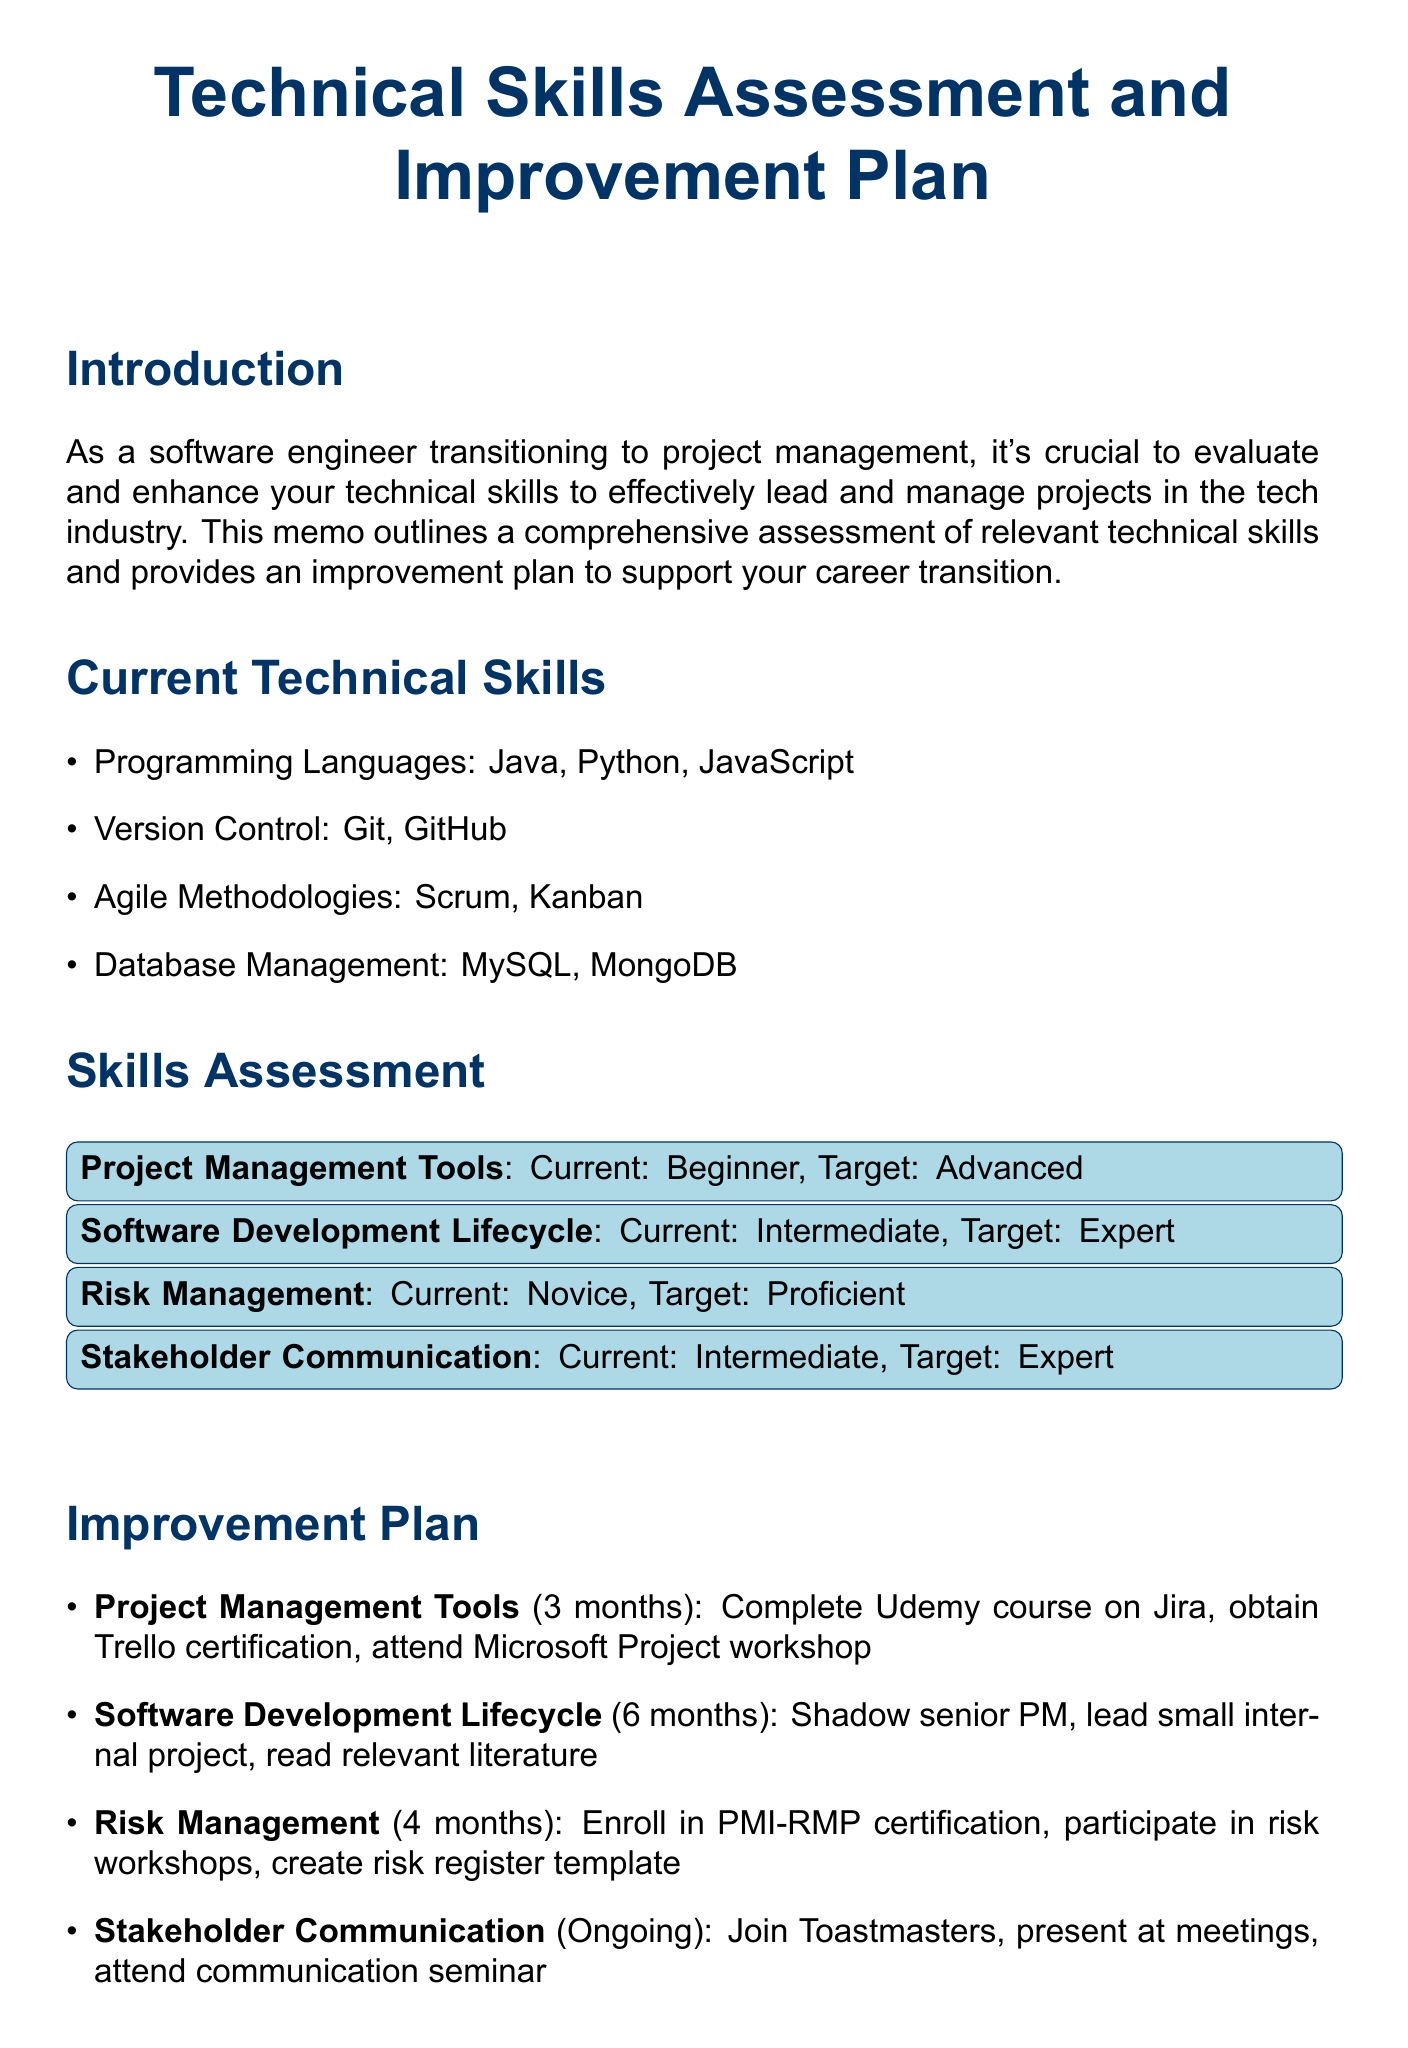What is the title of the memo? The title of the memo is indicated at the top of the document.
Answer: Technical Skills Assessment and Improvement Plan for Transition to Project Management What are the current skills in version control? The document lists skills under categories, and version control skills are specified.
Answer: Git, GitHub What is the target level for project management tools? The target level is defined in the skills assessment section of the memo.
Answer: Advanced How long is the improvement plan for risk management skills? The timeline for each improvement plan is provided in the improvement section.
Answer: 4 months What certification program should be enrolled in for risk management? The improvement plan specifies an action related to risk management certification.
Answer: PMI-RMP certification program What is one action for improving stakeholder communication skills? The improvement plan outlines multiple actions for gaining communication skills.
Answer: Join Toastmasters What is the current level of risk management skills? The current level is outlined in the skills assessment section of the memo.
Answer: Novice What should be done to improve software development lifecycle skills? This includes multiple actions, one of which defines leading a project.
Answer: Lead a small internal project from start to finish What is a consideration related to mentorship? The document provides recommendations for additional considerations in the transition.
Answer: Seek mentorship from experienced project managers 